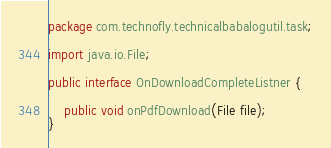<code> <loc_0><loc_0><loc_500><loc_500><_Java_>package com.technofly.technicalbabalogutil.task;

import java.io.File;

public interface OnDownloadCompleteListner {

    public void onPdfDownload(File file);
}
</code> 